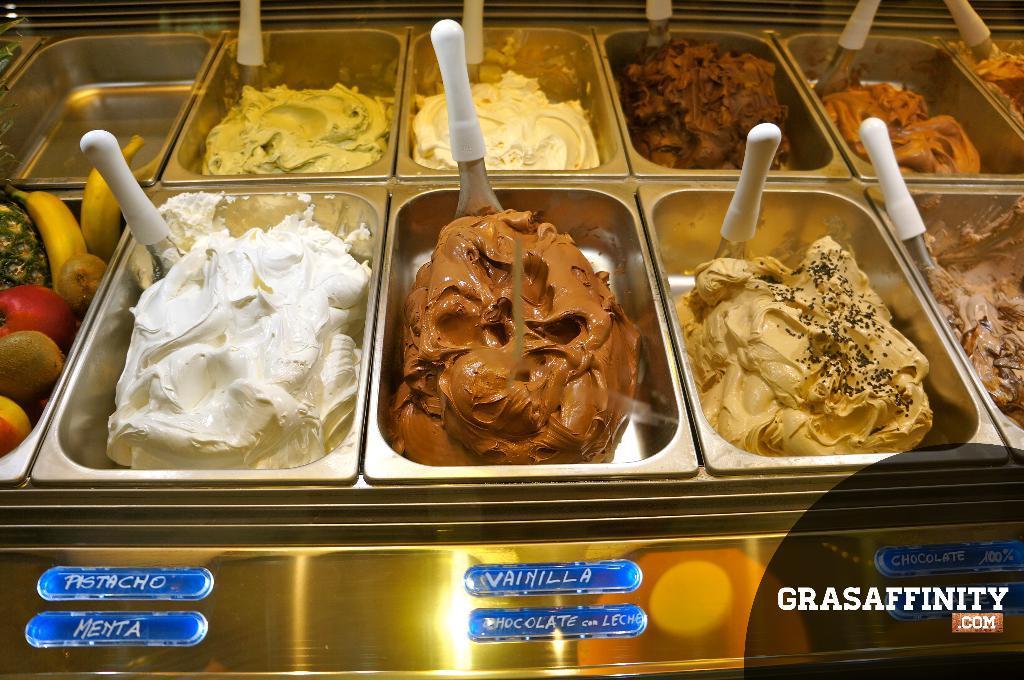Can you describe this image briefly? In this image there are few trays on the table. In the trays there are different varieties of ice creams and scoops in it. Left side there is a tray having some fruits in it. Bottom of the image there is some text. 